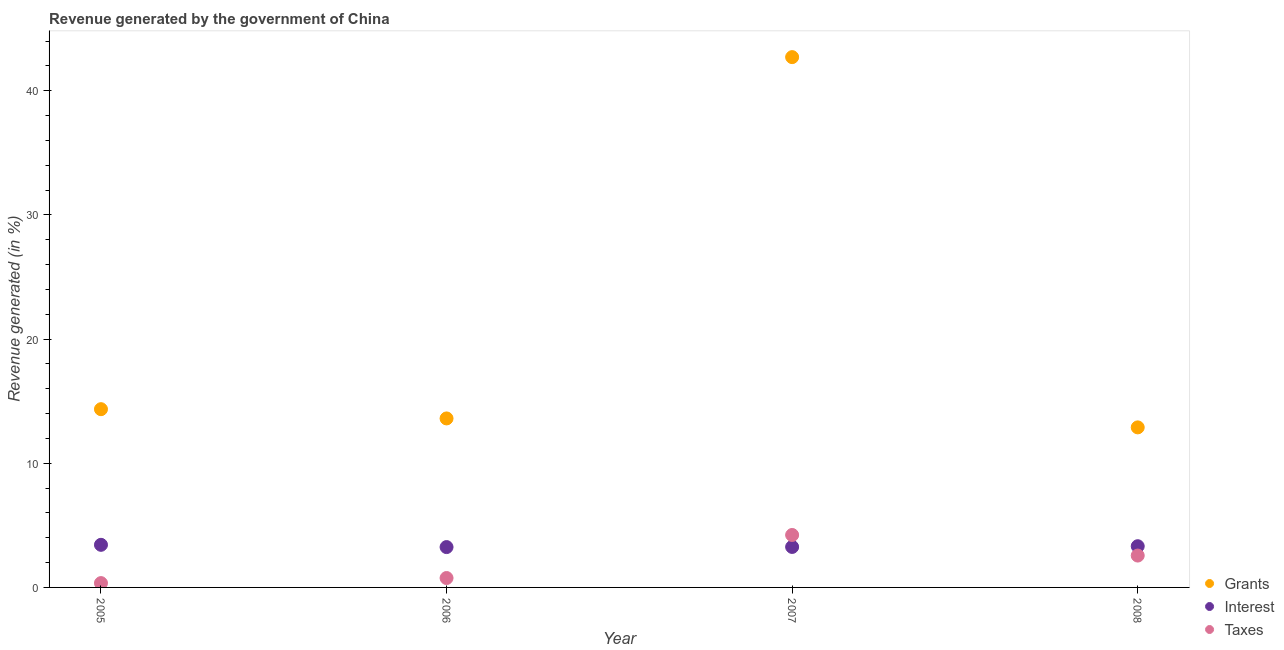What is the percentage of revenue generated by taxes in 2008?
Give a very brief answer. 2.57. Across all years, what is the maximum percentage of revenue generated by taxes?
Offer a very short reply. 4.22. Across all years, what is the minimum percentage of revenue generated by taxes?
Offer a very short reply. 0.35. In which year was the percentage of revenue generated by taxes maximum?
Ensure brevity in your answer.  2007. In which year was the percentage of revenue generated by interest minimum?
Offer a very short reply. 2006. What is the total percentage of revenue generated by grants in the graph?
Make the answer very short. 83.55. What is the difference between the percentage of revenue generated by grants in 2006 and that in 2008?
Provide a succinct answer. 0.72. What is the difference between the percentage of revenue generated by grants in 2006 and the percentage of revenue generated by interest in 2005?
Make the answer very short. 10.18. What is the average percentage of revenue generated by grants per year?
Give a very brief answer. 20.89. In the year 2005, what is the difference between the percentage of revenue generated by taxes and percentage of revenue generated by interest?
Give a very brief answer. -3.08. What is the ratio of the percentage of revenue generated by grants in 2006 to that in 2007?
Give a very brief answer. 0.32. Is the percentage of revenue generated by taxes in 2007 less than that in 2008?
Your response must be concise. No. What is the difference between the highest and the second highest percentage of revenue generated by grants?
Your answer should be very brief. 28.35. What is the difference between the highest and the lowest percentage of revenue generated by grants?
Provide a short and direct response. 29.82. Is it the case that in every year, the sum of the percentage of revenue generated by grants and percentage of revenue generated by interest is greater than the percentage of revenue generated by taxes?
Your response must be concise. Yes. Is the percentage of revenue generated by taxes strictly greater than the percentage of revenue generated by grants over the years?
Provide a short and direct response. No. Is the percentage of revenue generated by interest strictly less than the percentage of revenue generated by grants over the years?
Make the answer very short. Yes. Are the values on the major ticks of Y-axis written in scientific E-notation?
Make the answer very short. No. Does the graph contain grids?
Provide a succinct answer. No. What is the title of the graph?
Your answer should be compact. Revenue generated by the government of China. What is the label or title of the X-axis?
Keep it short and to the point. Year. What is the label or title of the Y-axis?
Your answer should be compact. Revenue generated (in %). What is the Revenue generated (in %) of Grants in 2005?
Keep it short and to the point. 14.35. What is the Revenue generated (in %) in Interest in 2005?
Keep it short and to the point. 3.43. What is the Revenue generated (in %) of Taxes in 2005?
Provide a short and direct response. 0.35. What is the Revenue generated (in %) of Grants in 2006?
Keep it short and to the point. 13.61. What is the Revenue generated (in %) in Interest in 2006?
Make the answer very short. 3.25. What is the Revenue generated (in %) in Taxes in 2006?
Your response must be concise. 0.76. What is the Revenue generated (in %) of Grants in 2007?
Offer a terse response. 42.7. What is the Revenue generated (in %) of Interest in 2007?
Give a very brief answer. 3.26. What is the Revenue generated (in %) of Taxes in 2007?
Provide a short and direct response. 4.22. What is the Revenue generated (in %) in Grants in 2008?
Provide a succinct answer. 12.89. What is the Revenue generated (in %) of Interest in 2008?
Your response must be concise. 3.32. What is the Revenue generated (in %) in Taxes in 2008?
Your answer should be compact. 2.57. Across all years, what is the maximum Revenue generated (in %) of Grants?
Your response must be concise. 42.7. Across all years, what is the maximum Revenue generated (in %) of Interest?
Give a very brief answer. 3.43. Across all years, what is the maximum Revenue generated (in %) of Taxes?
Your response must be concise. 4.22. Across all years, what is the minimum Revenue generated (in %) of Grants?
Keep it short and to the point. 12.89. Across all years, what is the minimum Revenue generated (in %) in Interest?
Offer a terse response. 3.25. Across all years, what is the minimum Revenue generated (in %) of Taxes?
Offer a terse response. 0.35. What is the total Revenue generated (in %) of Grants in the graph?
Give a very brief answer. 83.55. What is the total Revenue generated (in %) of Interest in the graph?
Offer a very short reply. 13.26. What is the total Revenue generated (in %) in Taxes in the graph?
Give a very brief answer. 7.89. What is the difference between the Revenue generated (in %) of Grants in 2005 and that in 2006?
Offer a very short reply. 0.74. What is the difference between the Revenue generated (in %) in Interest in 2005 and that in 2006?
Provide a short and direct response. 0.18. What is the difference between the Revenue generated (in %) in Taxes in 2005 and that in 2006?
Your answer should be compact. -0.41. What is the difference between the Revenue generated (in %) in Grants in 2005 and that in 2007?
Your answer should be very brief. -28.35. What is the difference between the Revenue generated (in %) in Interest in 2005 and that in 2007?
Offer a terse response. 0.17. What is the difference between the Revenue generated (in %) of Taxes in 2005 and that in 2007?
Your answer should be compact. -3.87. What is the difference between the Revenue generated (in %) in Grants in 2005 and that in 2008?
Ensure brevity in your answer.  1.47. What is the difference between the Revenue generated (in %) of Interest in 2005 and that in 2008?
Provide a succinct answer. 0.11. What is the difference between the Revenue generated (in %) in Taxes in 2005 and that in 2008?
Make the answer very short. -2.22. What is the difference between the Revenue generated (in %) in Grants in 2006 and that in 2007?
Ensure brevity in your answer.  -29.09. What is the difference between the Revenue generated (in %) of Interest in 2006 and that in 2007?
Your response must be concise. -0.01. What is the difference between the Revenue generated (in %) in Taxes in 2006 and that in 2007?
Provide a succinct answer. -3.47. What is the difference between the Revenue generated (in %) of Grants in 2006 and that in 2008?
Your response must be concise. 0.72. What is the difference between the Revenue generated (in %) of Interest in 2006 and that in 2008?
Provide a succinct answer. -0.07. What is the difference between the Revenue generated (in %) of Taxes in 2006 and that in 2008?
Provide a succinct answer. -1.81. What is the difference between the Revenue generated (in %) of Grants in 2007 and that in 2008?
Your answer should be compact. 29.82. What is the difference between the Revenue generated (in %) of Interest in 2007 and that in 2008?
Keep it short and to the point. -0.06. What is the difference between the Revenue generated (in %) in Taxes in 2007 and that in 2008?
Your answer should be compact. 1.66. What is the difference between the Revenue generated (in %) of Grants in 2005 and the Revenue generated (in %) of Interest in 2006?
Your answer should be very brief. 11.1. What is the difference between the Revenue generated (in %) in Grants in 2005 and the Revenue generated (in %) in Taxes in 2006?
Your answer should be compact. 13.6. What is the difference between the Revenue generated (in %) of Interest in 2005 and the Revenue generated (in %) of Taxes in 2006?
Provide a short and direct response. 2.67. What is the difference between the Revenue generated (in %) in Grants in 2005 and the Revenue generated (in %) in Interest in 2007?
Offer a terse response. 11.09. What is the difference between the Revenue generated (in %) in Grants in 2005 and the Revenue generated (in %) in Taxes in 2007?
Your answer should be very brief. 10.13. What is the difference between the Revenue generated (in %) in Interest in 2005 and the Revenue generated (in %) in Taxes in 2007?
Your answer should be compact. -0.79. What is the difference between the Revenue generated (in %) of Grants in 2005 and the Revenue generated (in %) of Interest in 2008?
Make the answer very short. 11.03. What is the difference between the Revenue generated (in %) in Grants in 2005 and the Revenue generated (in %) in Taxes in 2008?
Your answer should be compact. 11.79. What is the difference between the Revenue generated (in %) of Interest in 2005 and the Revenue generated (in %) of Taxes in 2008?
Offer a terse response. 0.86. What is the difference between the Revenue generated (in %) in Grants in 2006 and the Revenue generated (in %) in Interest in 2007?
Your response must be concise. 10.35. What is the difference between the Revenue generated (in %) in Grants in 2006 and the Revenue generated (in %) in Taxes in 2007?
Make the answer very short. 9.39. What is the difference between the Revenue generated (in %) in Interest in 2006 and the Revenue generated (in %) in Taxes in 2007?
Offer a terse response. -0.97. What is the difference between the Revenue generated (in %) of Grants in 2006 and the Revenue generated (in %) of Interest in 2008?
Provide a succinct answer. 10.29. What is the difference between the Revenue generated (in %) of Grants in 2006 and the Revenue generated (in %) of Taxes in 2008?
Your answer should be compact. 11.04. What is the difference between the Revenue generated (in %) of Interest in 2006 and the Revenue generated (in %) of Taxes in 2008?
Ensure brevity in your answer.  0.68. What is the difference between the Revenue generated (in %) in Grants in 2007 and the Revenue generated (in %) in Interest in 2008?
Your response must be concise. 39.38. What is the difference between the Revenue generated (in %) of Grants in 2007 and the Revenue generated (in %) of Taxes in 2008?
Your response must be concise. 40.14. What is the difference between the Revenue generated (in %) in Interest in 2007 and the Revenue generated (in %) in Taxes in 2008?
Keep it short and to the point. 0.69. What is the average Revenue generated (in %) of Grants per year?
Keep it short and to the point. 20.89. What is the average Revenue generated (in %) of Interest per year?
Make the answer very short. 3.31. What is the average Revenue generated (in %) in Taxes per year?
Provide a succinct answer. 1.97. In the year 2005, what is the difference between the Revenue generated (in %) of Grants and Revenue generated (in %) of Interest?
Provide a succinct answer. 10.92. In the year 2005, what is the difference between the Revenue generated (in %) of Grants and Revenue generated (in %) of Taxes?
Your response must be concise. 14. In the year 2005, what is the difference between the Revenue generated (in %) of Interest and Revenue generated (in %) of Taxes?
Ensure brevity in your answer.  3.08. In the year 2006, what is the difference between the Revenue generated (in %) in Grants and Revenue generated (in %) in Interest?
Ensure brevity in your answer.  10.36. In the year 2006, what is the difference between the Revenue generated (in %) of Grants and Revenue generated (in %) of Taxes?
Keep it short and to the point. 12.85. In the year 2006, what is the difference between the Revenue generated (in %) of Interest and Revenue generated (in %) of Taxes?
Provide a short and direct response. 2.49. In the year 2007, what is the difference between the Revenue generated (in %) of Grants and Revenue generated (in %) of Interest?
Keep it short and to the point. 39.44. In the year 2007, what is the difference between the Revenue generated (in %) in Grants and Revenue generated (in %) in Taxes?
Provide a short and direct response. 38.48. In the year 2007, what is the difference between the Revenue generated (in %) in Interest and Revenue generated (in %) in Taxes?
Your answer should be compact. -0.96. In the year 2008, what is the difference between the Revenue generated (in %) of Grants and Revenue generated (in %) of Interest?
Provide a succinct answer. 9.57. In the year 2008, what is the difference between the Revenue generated (in %) of Grants and Revenue generated (in %) of Taxes?
Give a very brief answer. 10.32. In the year 2008, what is the difference between the Revenue generated (in %) of Interest and Revenue generated (in %) of Taxes?
Offer a very short reply. 0.75. What is the ratio of the Revenue generated (in %) of Grants in 2005 to that in 2006?
Ensure brevity in your answer.  1.05. What is the ratio of the Revenue generated (in %) of Interest in 2005 to that in 2006?
Give a very brief answer. 1.06. What is the ratio of the Revenue generated (in %) of Taxes in 2005 to that in 2006?
Offer a very short reply. 0.46. What is the ratio of the Revenue generated (in %) of Grants in 2005 to that in 2007?
Give a very brief answer. 0.34. What is the ratio of the Revenue generated (in %) of Interest in 2005 to that in 2007?
Your answer should be compact. 1.05. What is the ratio of the Revenue generated (in %) in Taxes in 2005 to that in 2007?
Offer a terse response. 0.08. What is the ratio of the Revenue generated (in %) of Grants in 2005 to that in 2008?
Keep it short and to the point. 1.11. What is the ratio of the Revenue generated (in %) in Interest in 2005 to that in 2008?
Ensure brevity in your answer.  1.03. What is the ratio of the Revenue generated (in %) in Taxes in 2005 to that in 2008?
Ensure brevity in your answer.  0.14. What is the ratio of the Revenue generated (in %) in Grants in 2006 to that in 2007?
Make the answer very short. 0.32. What is the ratio of the Revenue generated (in %) of Interest in 2006 to that in 2007?
Make the answer very short. 1. What is the ratio of the Revenue generated (in %) of Taxes in 2006 to that in 2007?
Your response must be concise. 0.18. What is the ratio of the Revenue generated (in %) in Grants in 2006 to that in 2008?
Your answer should be very brief. 1.06. What is the ratio of the Revenue generated (in %) of Interest in 2006 to that in 2008?
Your answer should be compact. 0.98. What is the ratio of the Revenue generated (in %) of Taxes in 2006 to that in 2008?
Your response must be concise. 0.29. What is the ratio of the Revenue generated (in %) of Grants in 2007 to that in 2008?
Keep it short and to the point. 3.31. What is the ratio of the Revenue generated (in %) of Interest in 2007 to that in 2008?
Your answer should be very brief. 0.98. What is the ratio of the Revenue generated (in %) in Taxes in 2007 to that in 2008?
Make the answer very short. 1.65. What is the difference between the highest and the second highest Revenue generated (in %) in Grants?
Your answer should be very brief. 28.35. What is the difference between the highest and the second highest Revenue generated (in %) in Interest?
Your answer should be very brief. 0.11. What is the difference between the highest and the second highest Revenue generated (in %) in Taxes?
Your answer should be very brief. 1.66. What is the difference between the highest and the lowest Revenue generated (in %) in Grants?
Ensure brevity in your answer.  29.82. What is the difference between the highest and the lowest Revenue generated (in %) of Interest?
Your answer should be very brief. 0.18. What is the difference between the highest and the lowest Revenue generated (in %) in Taxes?
Your answer should be very brief. 3.87. 